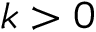<formula> <loc_0><loc_0><loc_500><loc_500>k > 0</formula> 